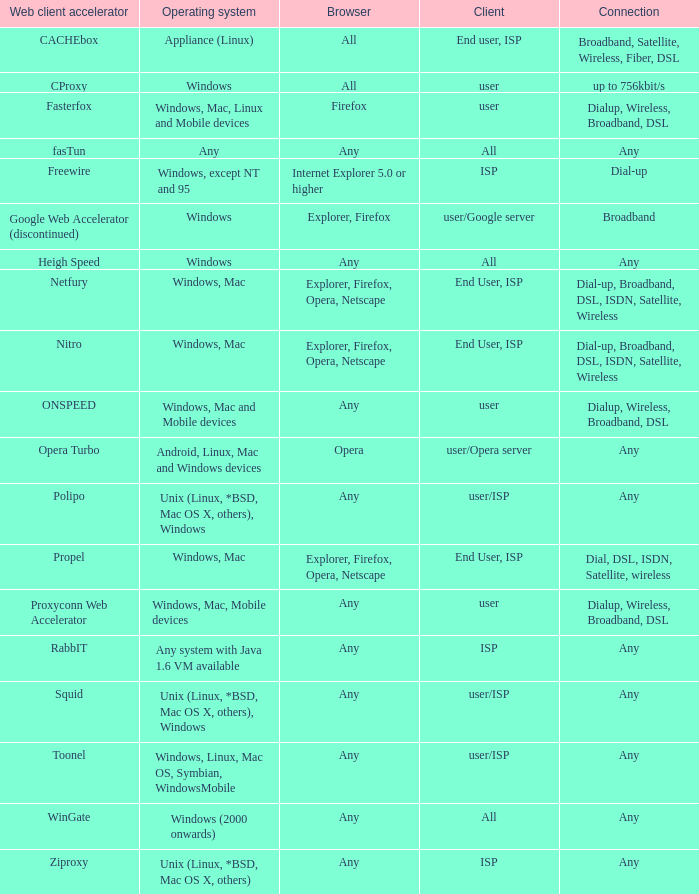What is the connection for the proxyconn web accelerator web client accelerator? Dialup, Wireless, Broadband, DSL. 